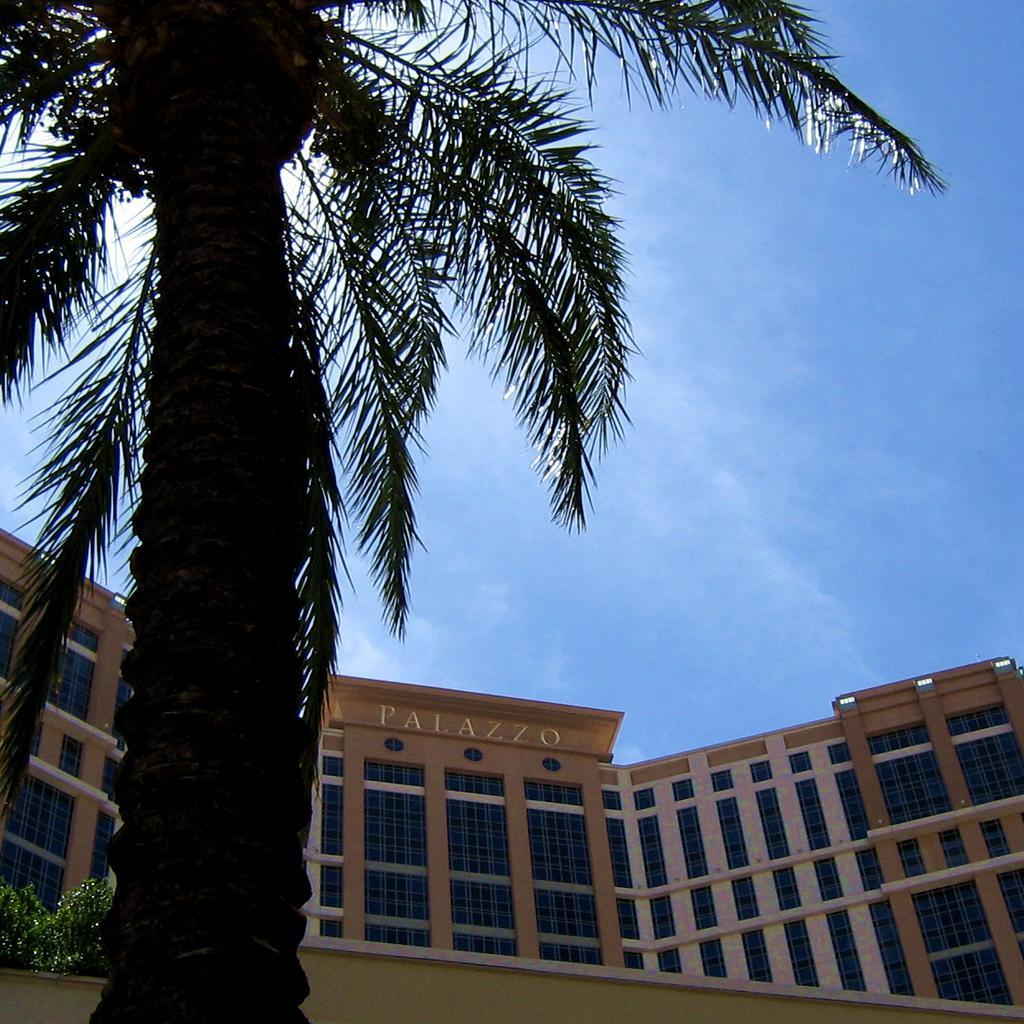Please provide a concise description of this image. This is an outside view. On the left side there is a coconut tree and some plants. In the background there is a building. On the top of the image I can see the sky in blue color. 